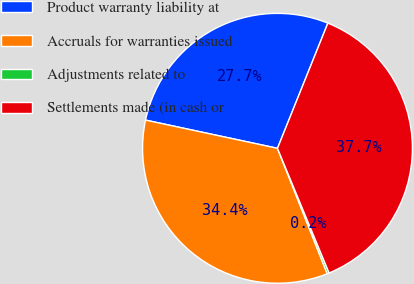Convert chart. <chart><loc_0><loc_0><loc_500><loc_500><pie_chart><fcel>Product warranty liability at<fcel>Accruals for warranties issued<fcel>Adjustments related to<fcel>Settlements made (in cash or<nl><fcel>27.74%<fcel>34.36%<fcel>0.24%<fcel>37.66%<nl></chart> 